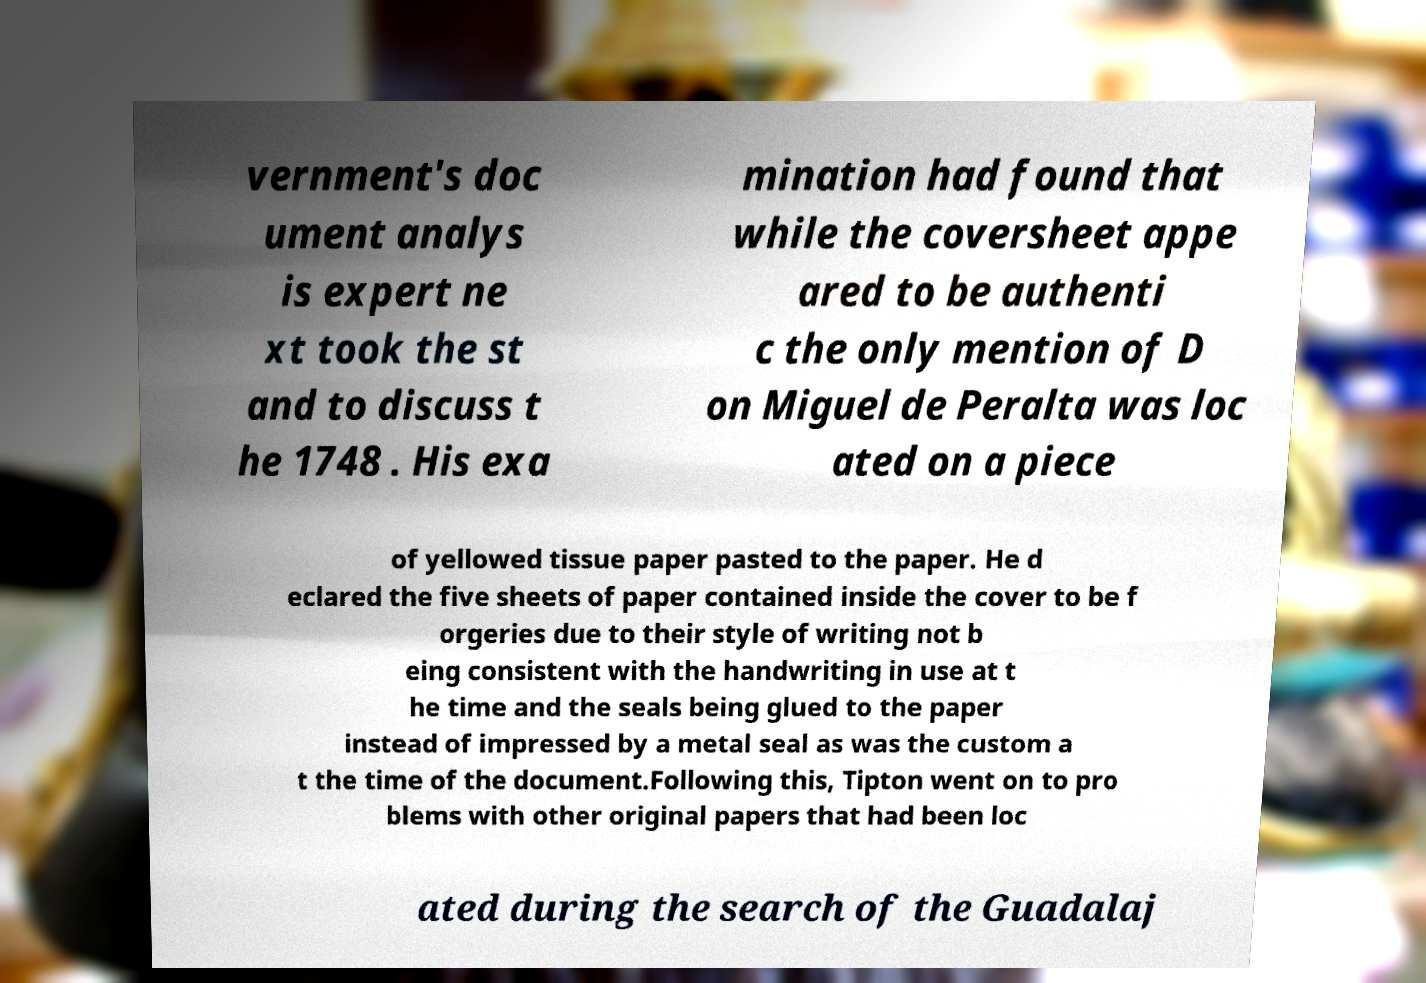Could you extract and type out the text from this image? vernment's doc ument analys is expert ne xt took the st and to discuss t he 1748 . His exa mination had found that while the coversheet appe ared to be authenti c the only mention of D on Miguel de Peralta was loc ated on a piece of yellowed tissue paper pasted to the paper. He d eclared the five sheets of paper contained inside the cover to be f orgeries due to their style of writing not b eing consistent with the handwriting in use at t he time and the seals being glued to the paper instead of impressed by a metal seal as was the custom a t the time of the document.Following this, Tipton went on to pro blems with other original papers that had been loc ated during the search of the Guadalaj 